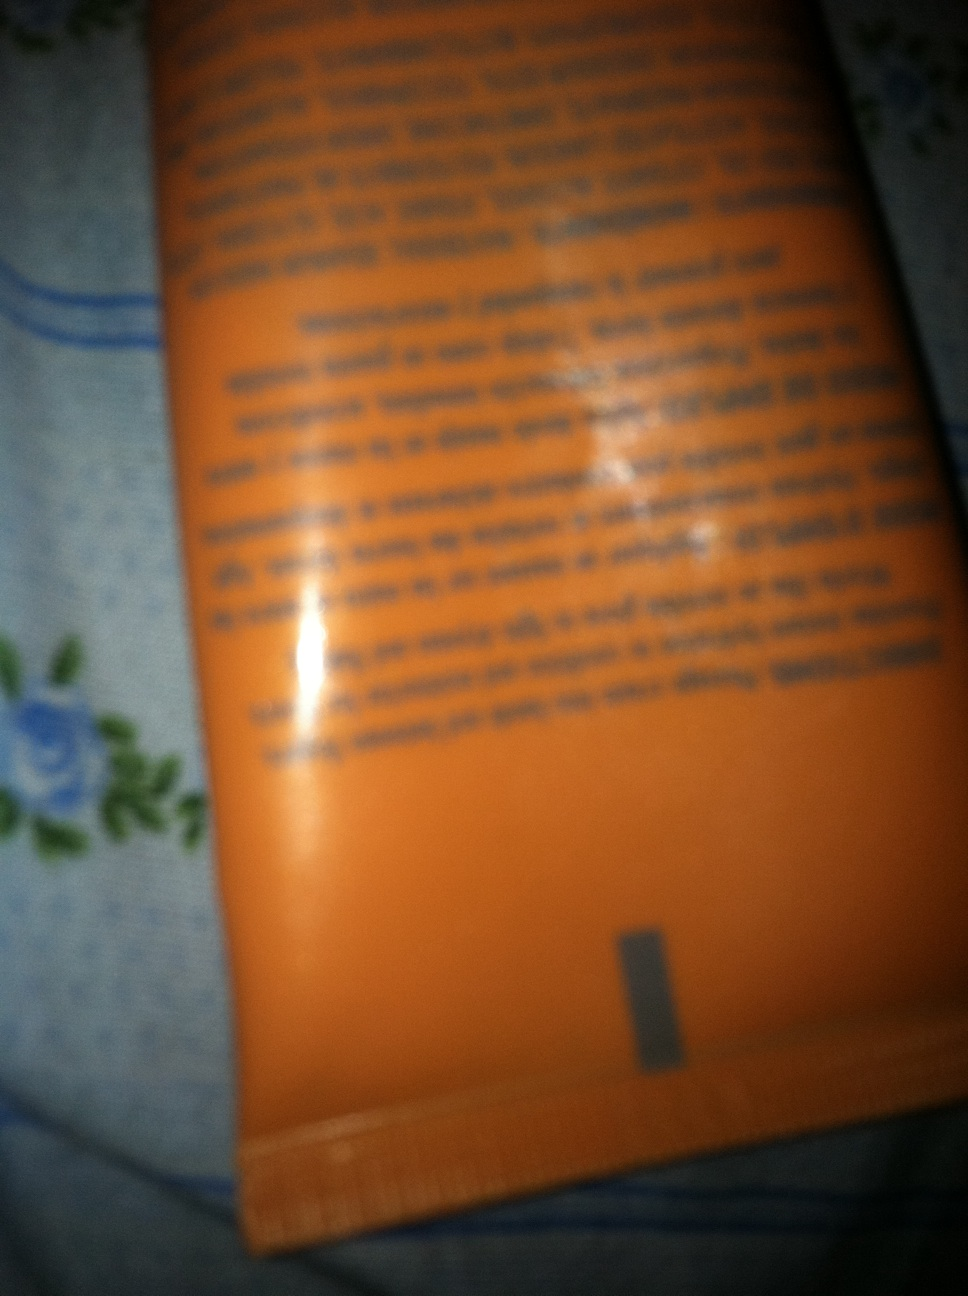Does the color of the tube indicate what kind of product it could be? Orange-colored packaging is often used for vibrant, citrus-scented products, or brands that want to convey energy and vibrancy. This hue does not definitively determine the type of product, but it can sometimes hint at its sensory attributes or branding style. 